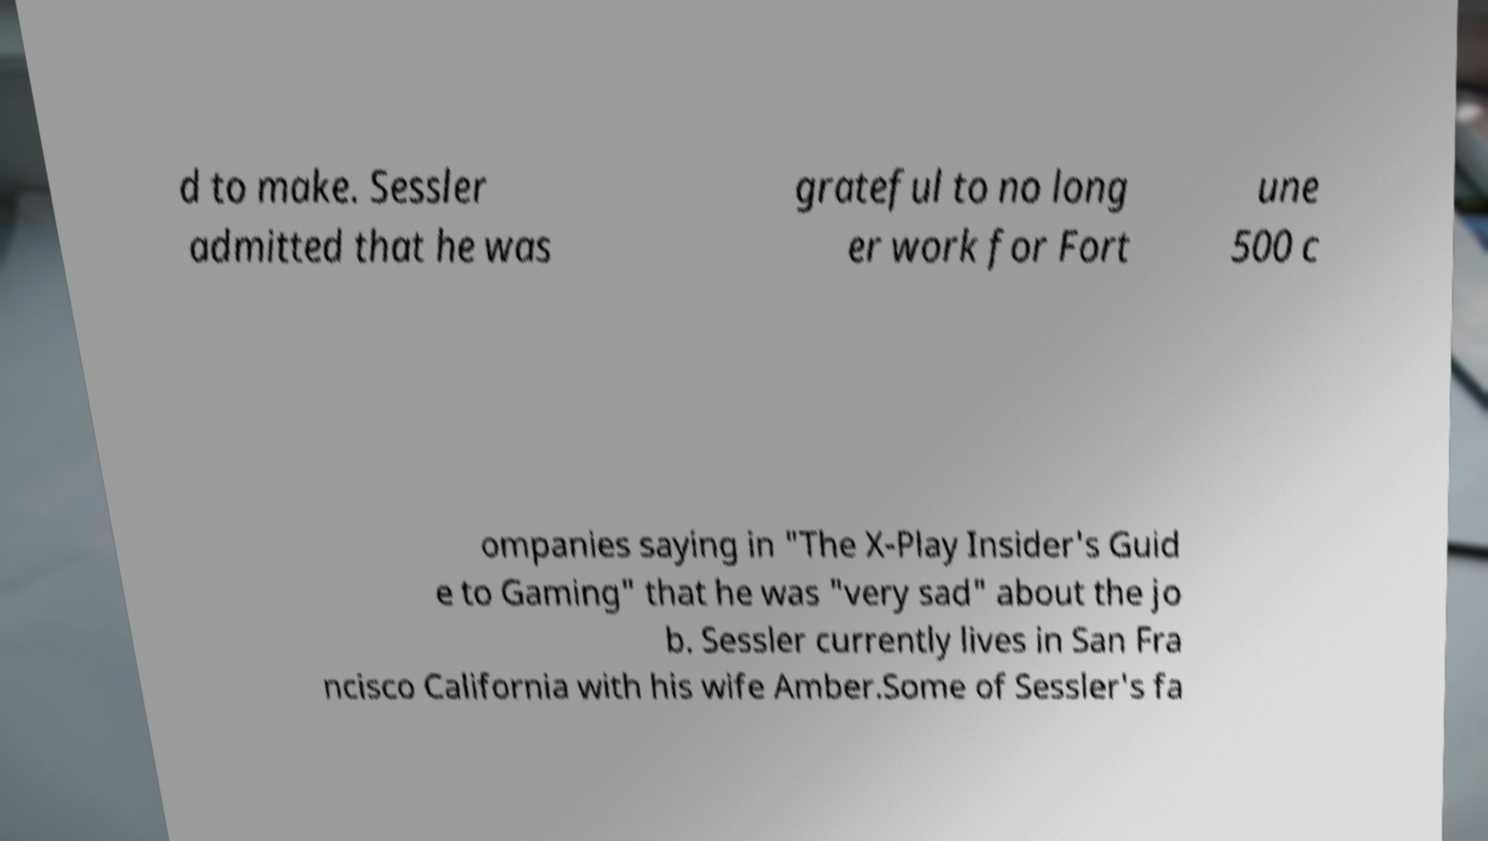I need the written content from this picture converted into text. Can you do that? d to make. Sessler admitted that he was grateful to no long er work for Fort une 500 c ompanies saying in "The X-Play Insider's Guid e to Gaming" that he was "very sad" about the jo b. Sessler currently lives in San Fra ncisco California with his wife Amber.Some of Sessler's fa 